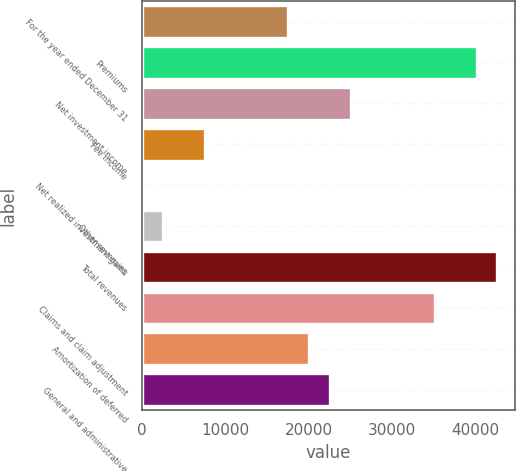Convert chart to OTSL. <chart><loc_0><loc_0><loc_500><loc_500><bar_chart><fcel>For the year ended December 31<fcel>Premiums<fcel>Net investment income<fcel>Fee income<fcel>Net realized investment gains<fcel>Other revenues<fcel>Total revenues<fcel>Claims and claim adjustment<fcel>Amortization of deferred<fcel>General and administrative<nl><fcel>17566.3<fcel>40137.4<fcel>25090<fcel>7534.7<fcel>11<fcel>2518.9<fcel>42645.3<fcel>35121.6<fcel>20074.2<fcel>22582.1<nl></chart> 